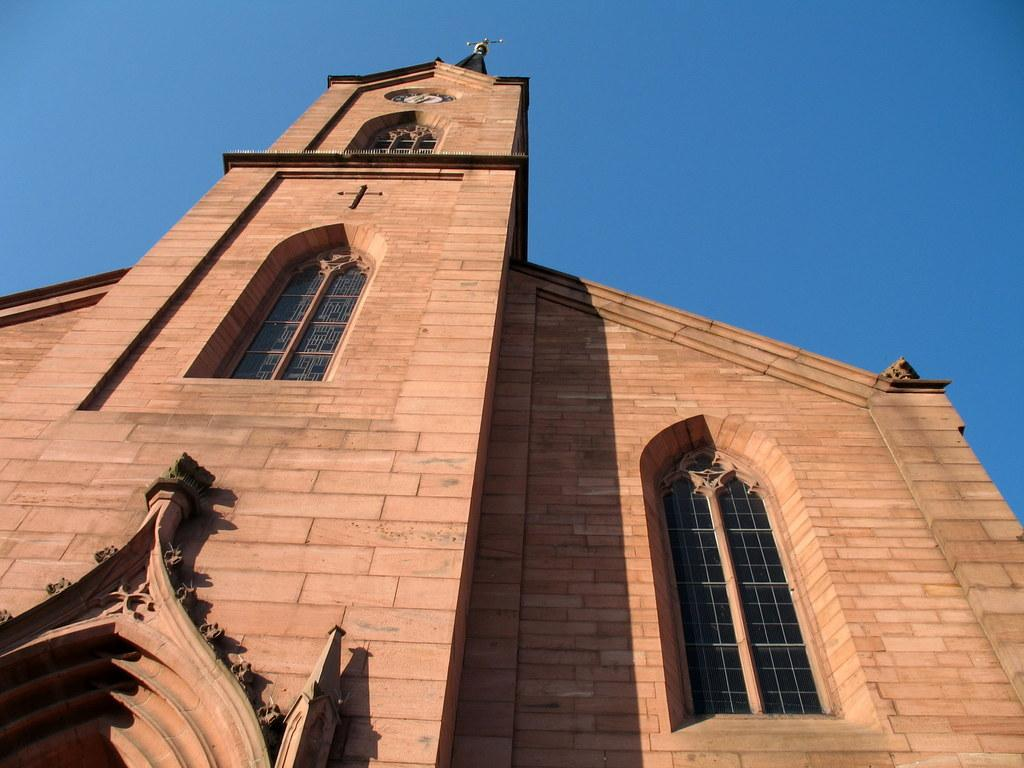What is the main structure in the image? There is a building in the image. What feature can be seen on the building? The building has windows. What color is the sky in the image? The sky is blue in color. What type of lamp is hanging from the ceiling in the image? There is no lamp present in the image; it only features a building and a blue sky. 